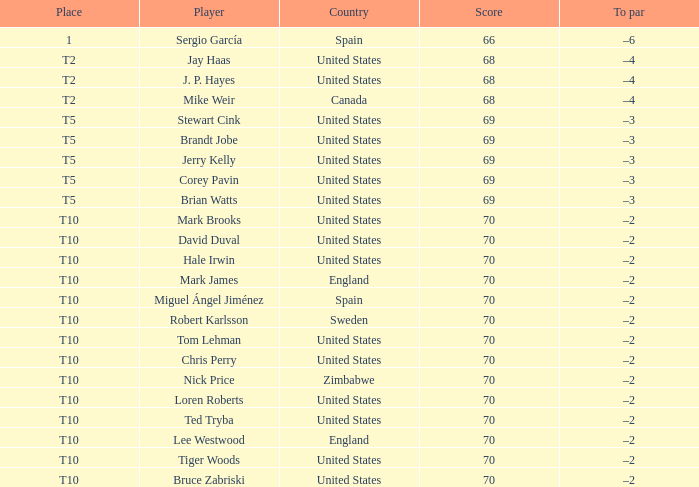What was the to par for the golfer who ranked t5? –3, –3, –3, –3, –3. 